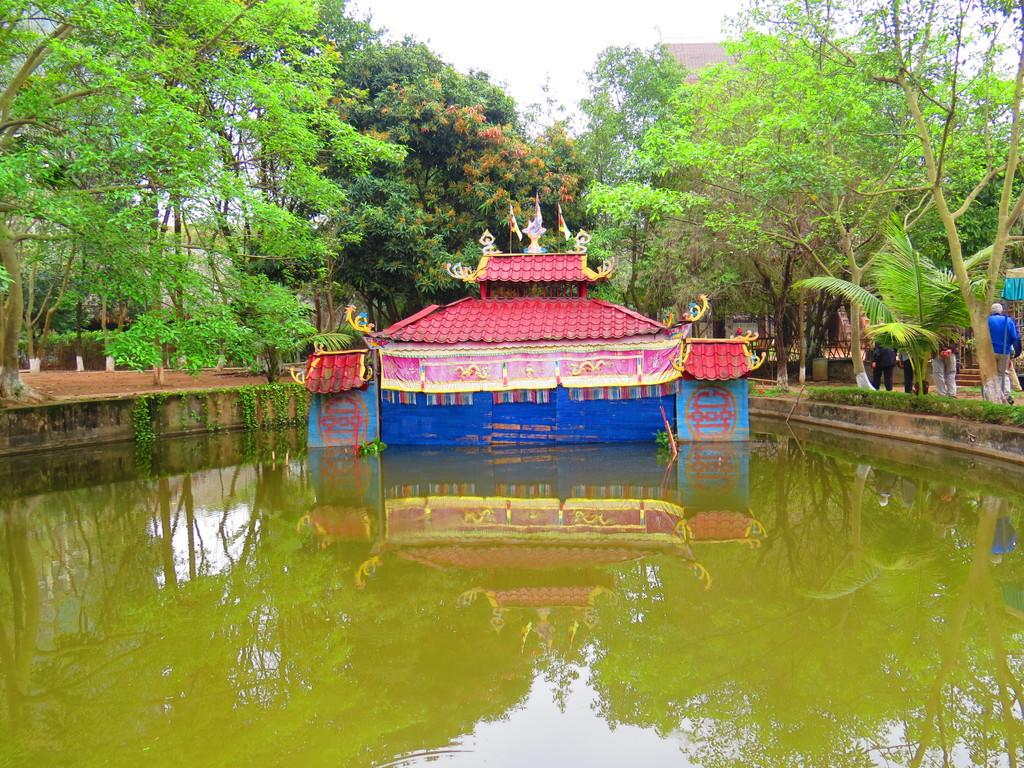What is visible in the sky in the image? The sky is visible in the image. What type of vegetation can be seen in the image? There are trees in the image. What natural element is visible in the image? There is water visible in the image. What type of ground surface is present in the image? There is grass visible in the image. What type of structure is present in the image? There is a house in the image. What living organisms are present in the image? There are people in the image. What other objects are present in the image? There are other objects in the image. What hobbies are the people in the image participating in? The provided facts do not mention any specific hobbies that the people in the image are participating in. What type of nose can be seen on the trees in the image? Trees do not have noses, so this question is not applicable to the image. 